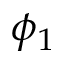<formula> <loc_0><loc_0><loc_500><loc_500>\phi _ { 1 }</formula> 